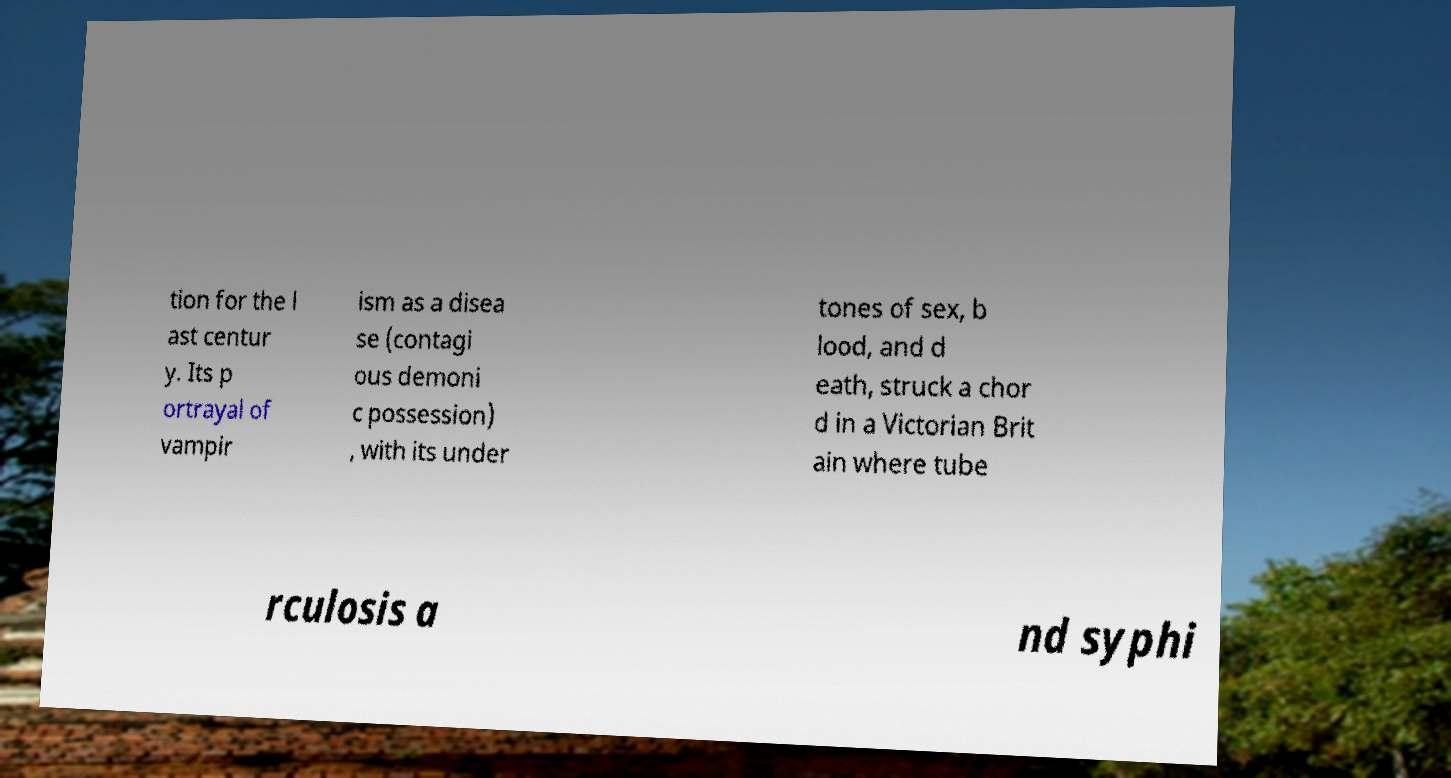Could you extract and type out the text from this image? tion for the l ast centur y. Its p ortrayal of vampir ism as a disea se (contagi ous demoni c possession) , with its under tones of sex, b lood, and d eath, struck a chor d in a Victorian Brit ain where tube rculosis a nd syphi 